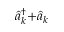<formula> <loc_0><loc_0><loc_500><loc_500>\hat { a } _ { k } ^ { \dagger } { + } \hat { a } _ { k }</formula> 